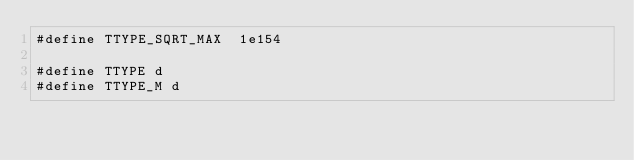Convert code to text. <code><loc_0><loc_0><loc_500><loc_500><_C_>#define TTYPE_SQRT_MAX  1e154

#define TTYPE d
#define TTYPE_M d

</code> 